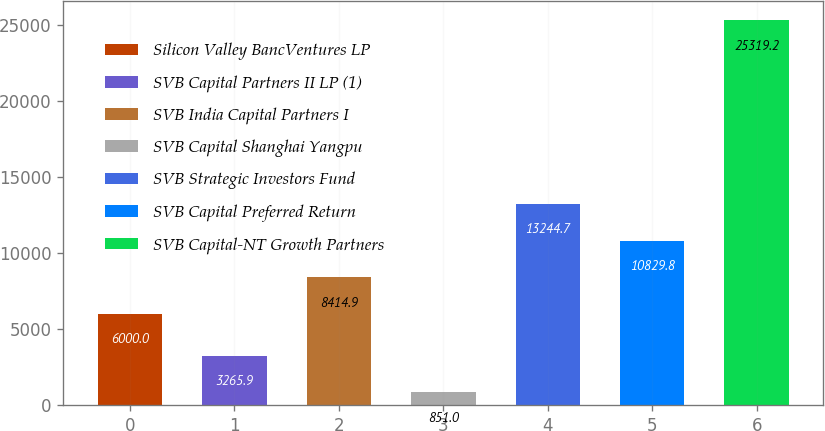<chart> <loc_0><loc_0><loc_500><loc_500><bar_chart><fcel>Silicon Valley BancVentures LP<fcel>SVB Capital Partners II LP (1)<fcel>SVB India Capital Partners I<fcel>SVB Capital Shanghai Yangpu<fcel>SVB Strategic Investors Fund<fcel>SVB Capital Preferred Return<fcel>SVB Capital-NT Growth Partners<nl><fcel>6000<fcel>3265.9<fcel>8414.9<fcel>851<fcel>13244.7<fcel>10829.8<fcel>25319.2<nl></chart> 